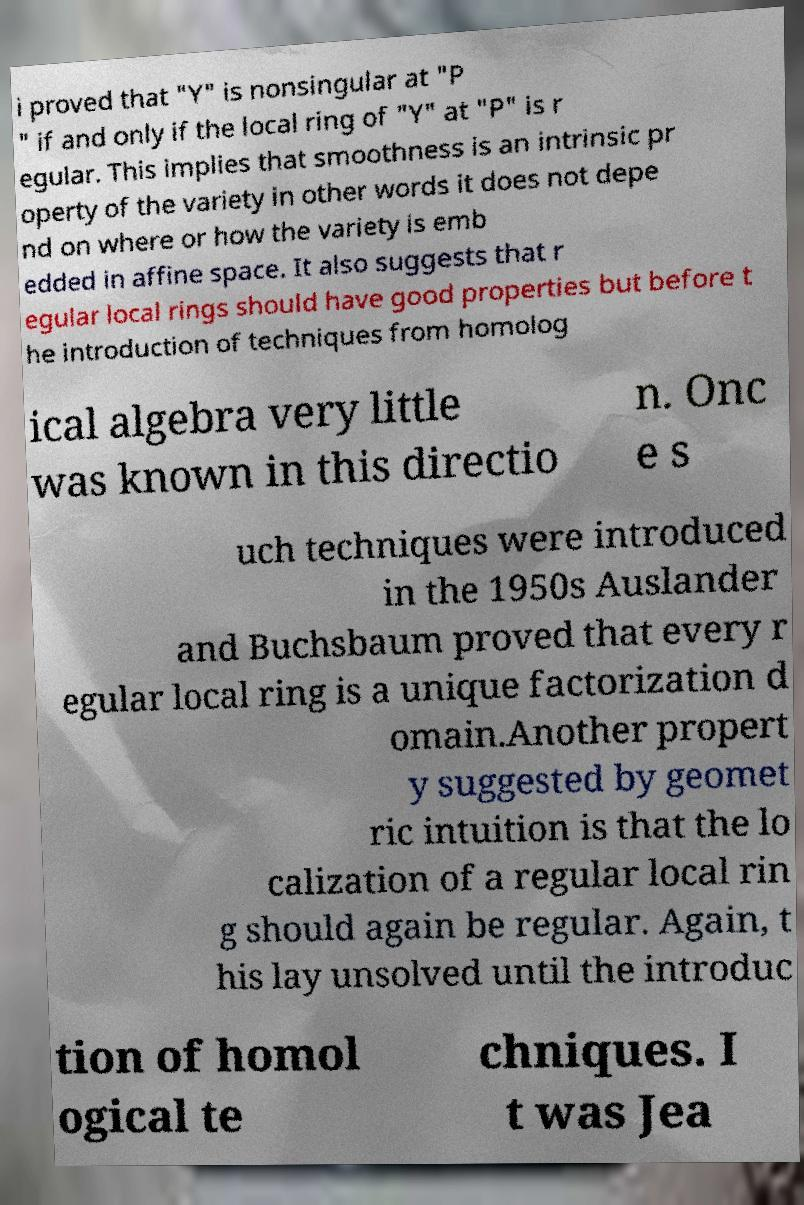What messages or text are displayed in this image? I need them in a readable, typed format. i proved that "Y" is nonsingular at "P " if and only if the local ring of "Y" at "P" is r egular. This implies that smoothness is an intrinsic pr operty of the variety in other words it does not depe nd on where or how the variety is emb edded in affine space. It also suggests that r egular local rings should have good properties but before t he introduction of techniques from homolog ical algebra very little was known in this directio n. Onc e s uch techniques were introduced in the 1950s Auslander and Buchsbaum proved that every r egular local ring is a unique factorization d omain.Another propert y suggested by geomet ric intuition is that the lo calization of a regular local rin g should again be regular. Again, t his lay unsolved until the introduc tion of homol ogical te chniques. I t was Jea 